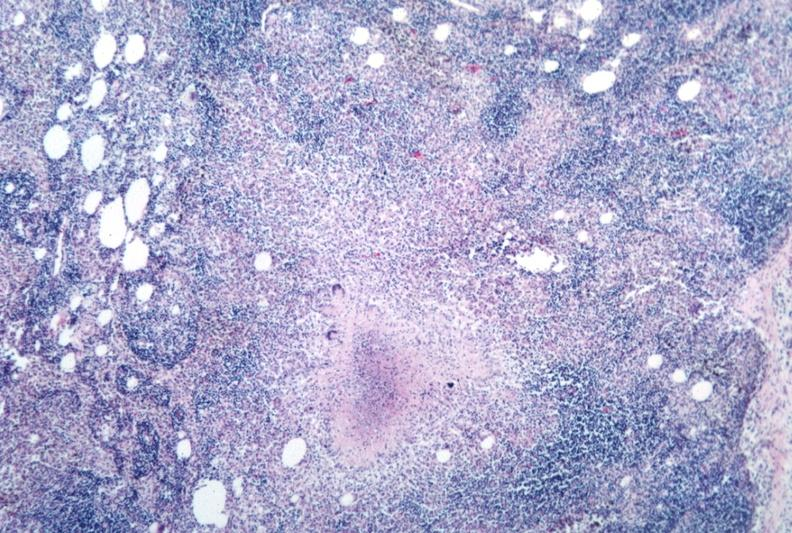what is present?
Answer the question using a single word or phrase. Lymph node 